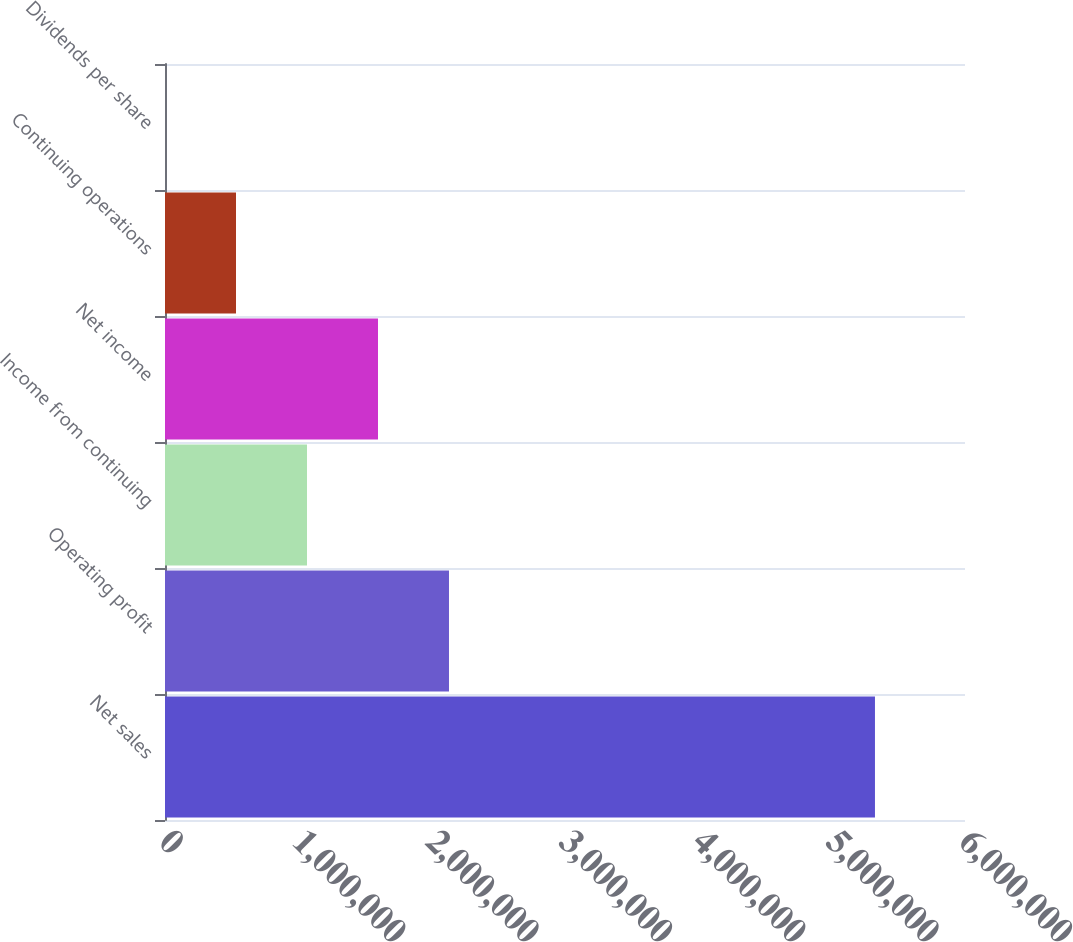Convert chart to OTSL. <chart><loc_0><loc_0><loc_500><loc_500><bar_chart><fcel>Net sales<fcel>Operating profit<fcel>Income from continuing<fcel>Net income<fcel>Continuing operations<fcel>Dividends per share<nl><fcel>5.32475e+06<fcel>2.1299e+06<fcel>1.06495e+06<fcel>1.59742e+06<fcel>532475<fcel>0.3<nl></chart> 